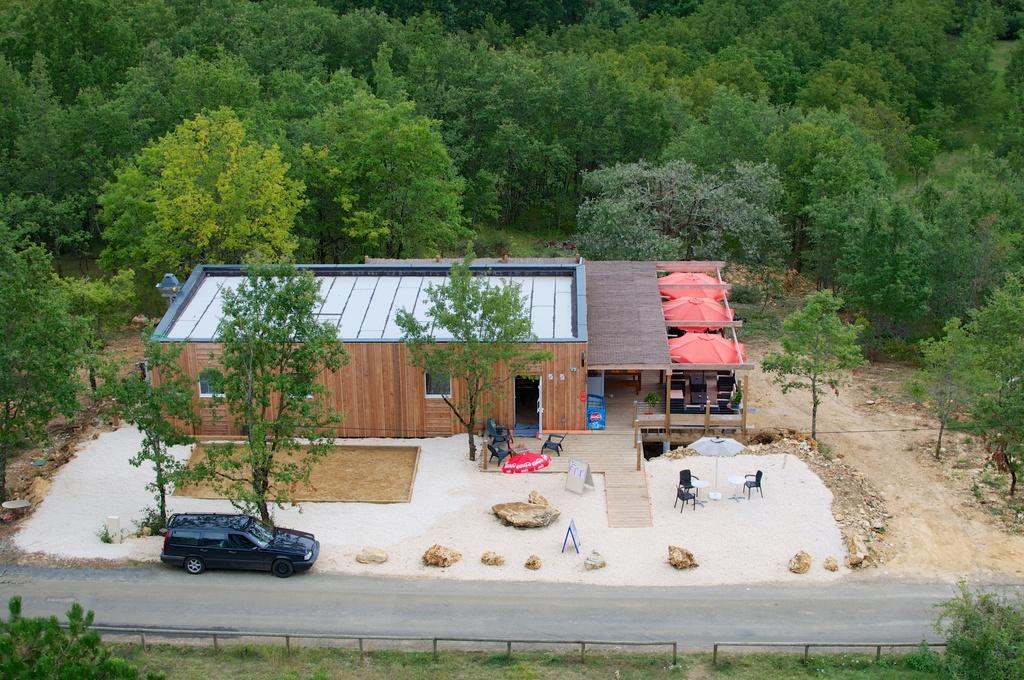Please provide a concise description of this image. This image consists of a house. On the right, we can see three umbrellas and chairs. At the bottom, there is a road on which we can see a car parked. In the background, there are many trees. 